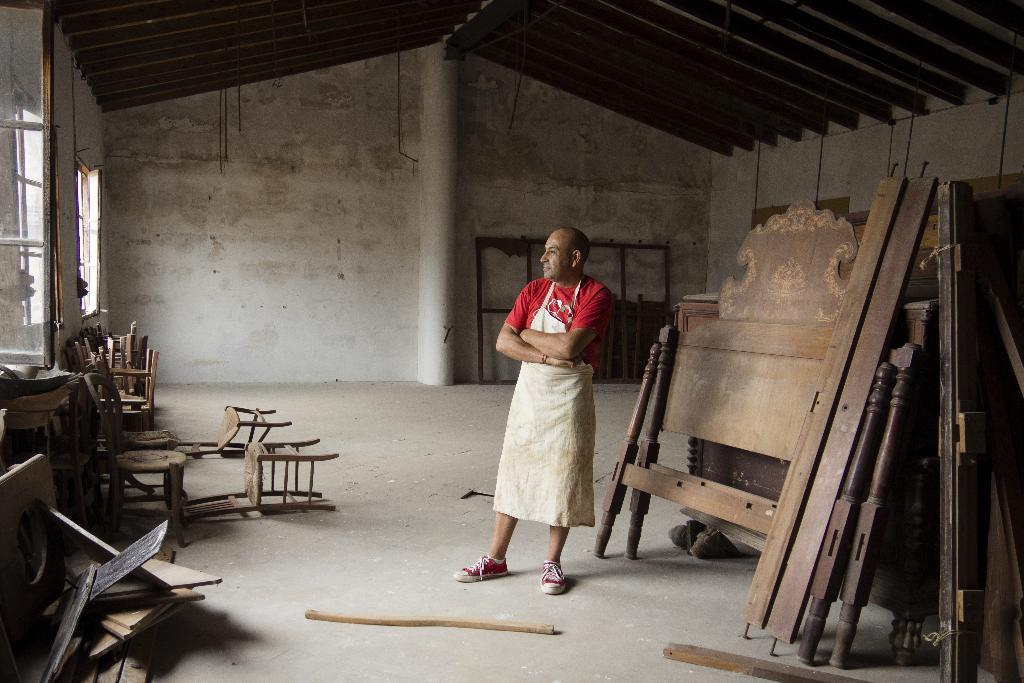What is the main subject of the image? There is a person in the image. What is the person wearing on their upper body? The person is wearing a red t-shirt. What additional clothing item is the person wearing? The person is wearing an apron. What type of footwear is the person wearing? The person is wearing red shoes. Where is the person located in the image? The person is standing inside a building. Can you describe the condition of the furniture in the building? The furniture in the building is worn. What architectural feature can be seen on the left side wall of the building? There are windows on the left side wall of the building. How much profit did the person make from the land in the image? There is no information about profit or land in the image; it only shows a person wearing a red t-shirt, apron, and red shoes, standing inside a building with worn furniture and windows on the left side wall. 